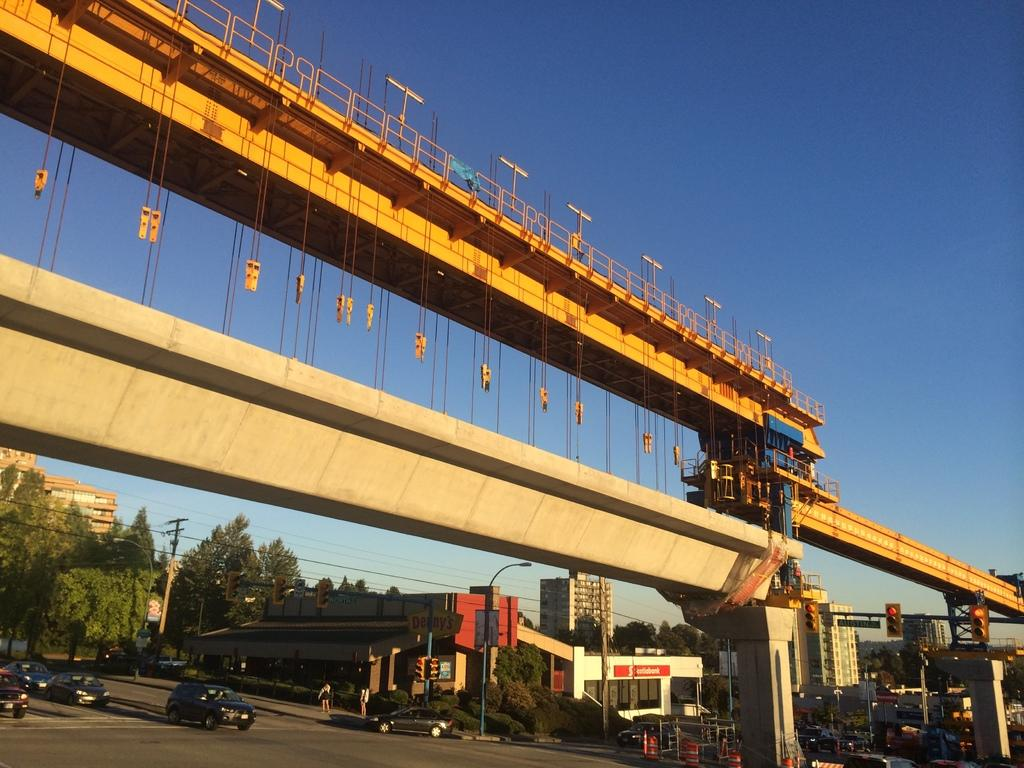What is happening in the middle of the image? There is construction in the middle of the image. What can be seen on the left side of the image? There are vehicles moving on the road on the left side of the image. What type of structures are visible in the image? There are buildings visible in the image. What is the color of the sky in the image? The sky is blue in color and visible at the top of the image. Can you see a writer working on a novel in the image? There is no writer or novel present in the image. How many fingers are visible on the construction worker's hand in the image? The image does not show any construction worker's hand, so it is not possible to determine the number of fingers visible. 